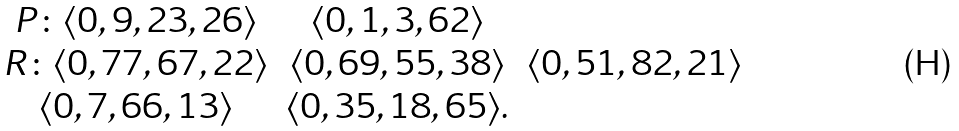<formula> <loc_0><loc_0><loc_500><loc_500>\begin{array} { c c c } P \colon \langle 0 , 9 , 2 3 , 2 6 \rangle & \langle 0 , 1 , 3 , 6 2 \rangle \\ R \colon \langle 0 , 7 7 , 6 7 , 2 2 \rangle & \langle 0 , 6 9 , 5 5 , 3 8 \rangle & \langle 0 , 5 1 , 8 2 , 2 1 \rangle \\ \langle 0 , 7 , 6 6 , 1 3 \rangle & \langle 0 , 3 5 , 1 8 , 6 5 \rangle . \\ \end{array}</formula> 